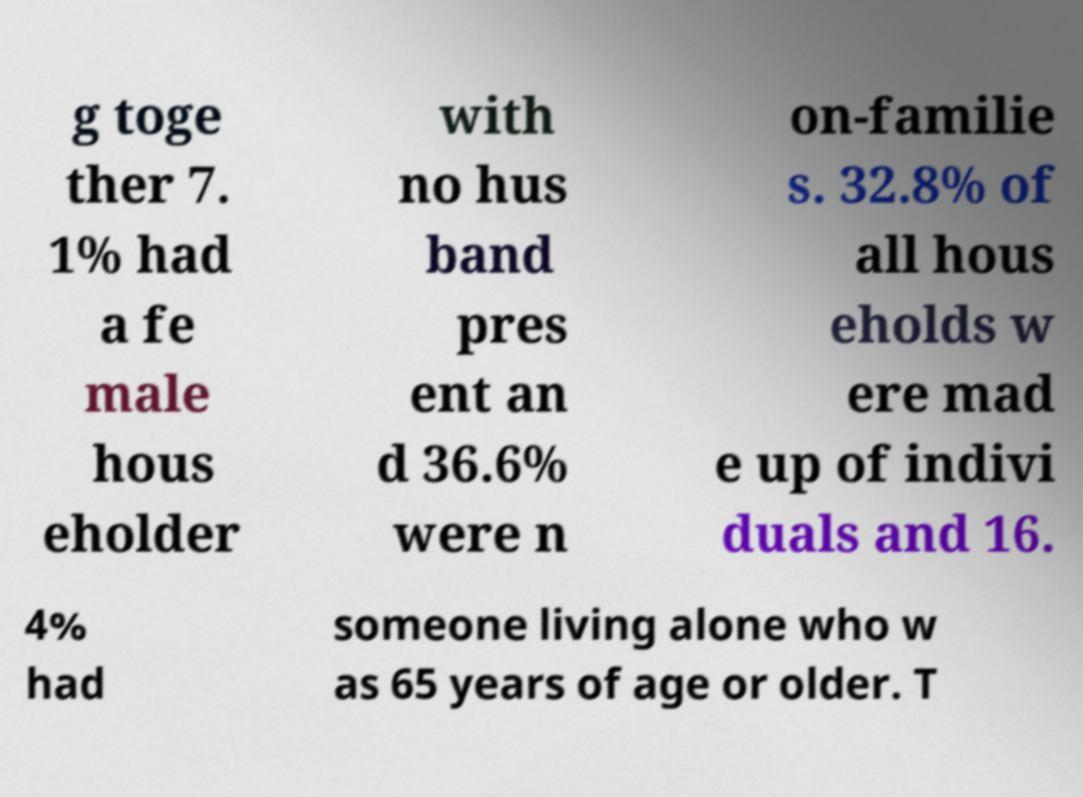Could you extract and type out the text from this image? g toge ther 7. 1% had a fe male hous eholder with no hus band pres ent an d 36.6% were n on-familie s. 32.8% of all hous eholds w ere mad e up of indivi duals and 16. 4% had someone living alone who w as 65 years of age or older. T 